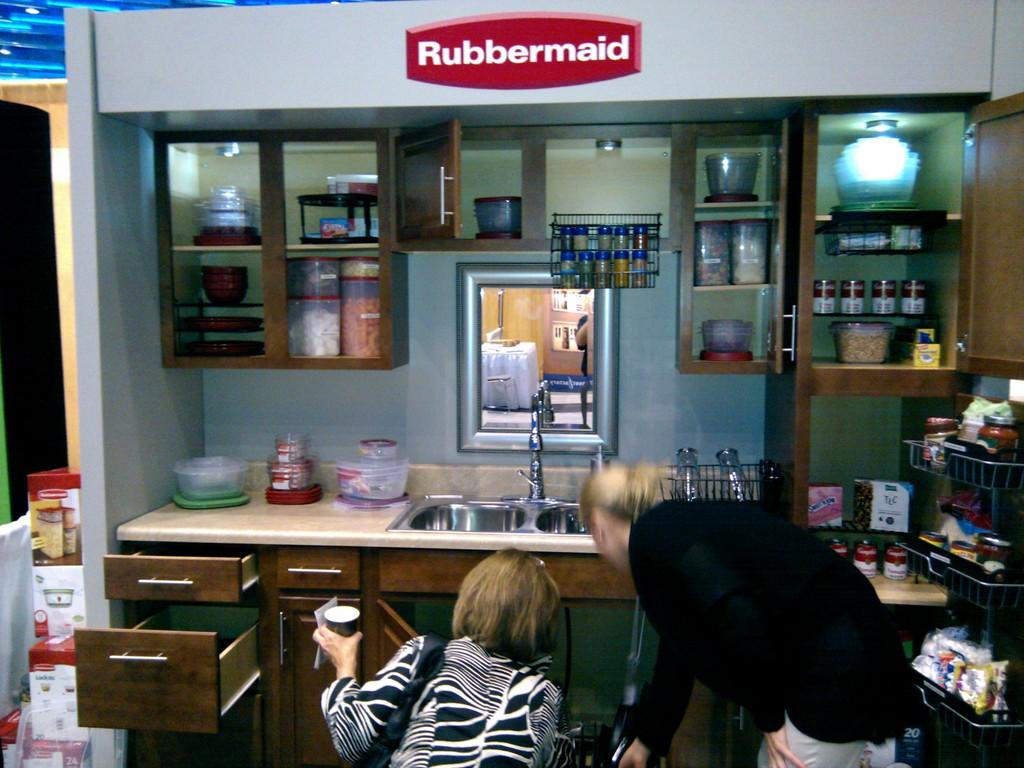Provide a one-sentence caption for the provided image. Two women are looking under a kitchen sink with a Rubbermaid sign on the wall. 